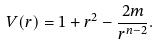<formula> <loc_0><loc_0><loc_500><loc_500>V ( r ) = 1 + r ^ { 2 } - \frac { 2 m } { r ^ { n - 2 } } .</formula> 